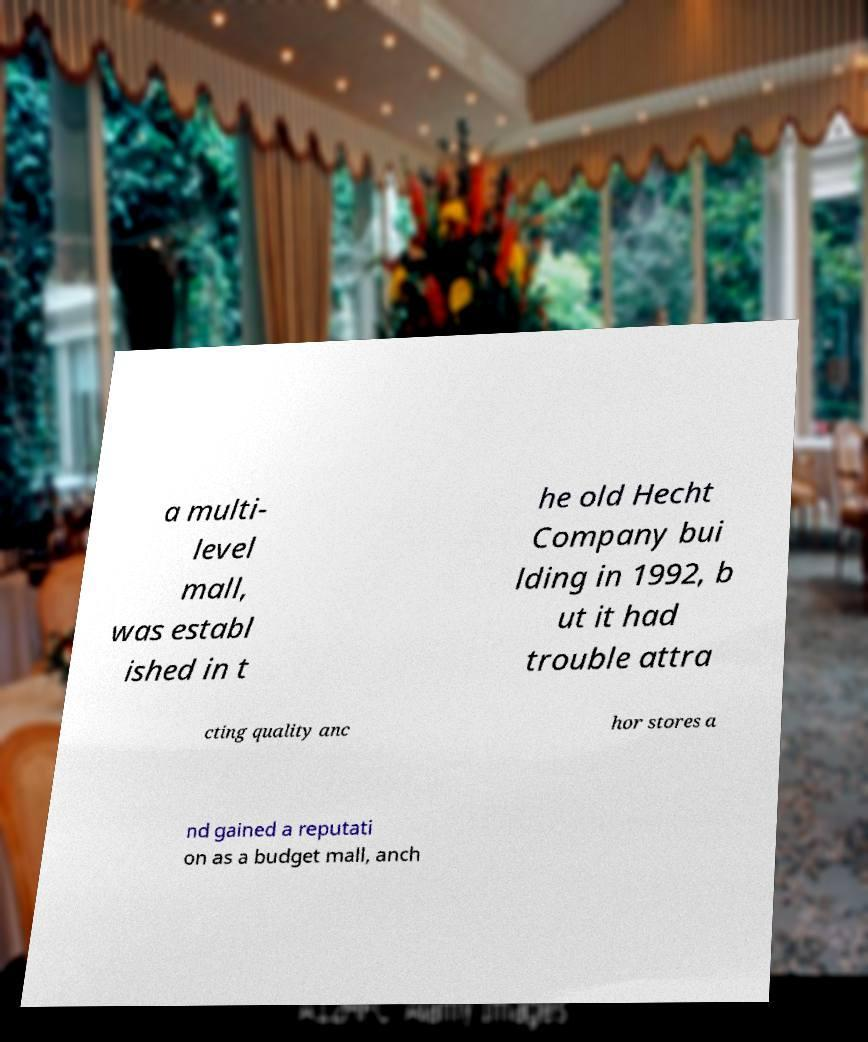Could you extract and type out the text from this image? a multi- level mall, was establ ished in t he old Hecht Company bui lding in 1992, b ut it had trouble attra cting quality anc hor stores a nd gained a reputati on as a budget mall, anch 